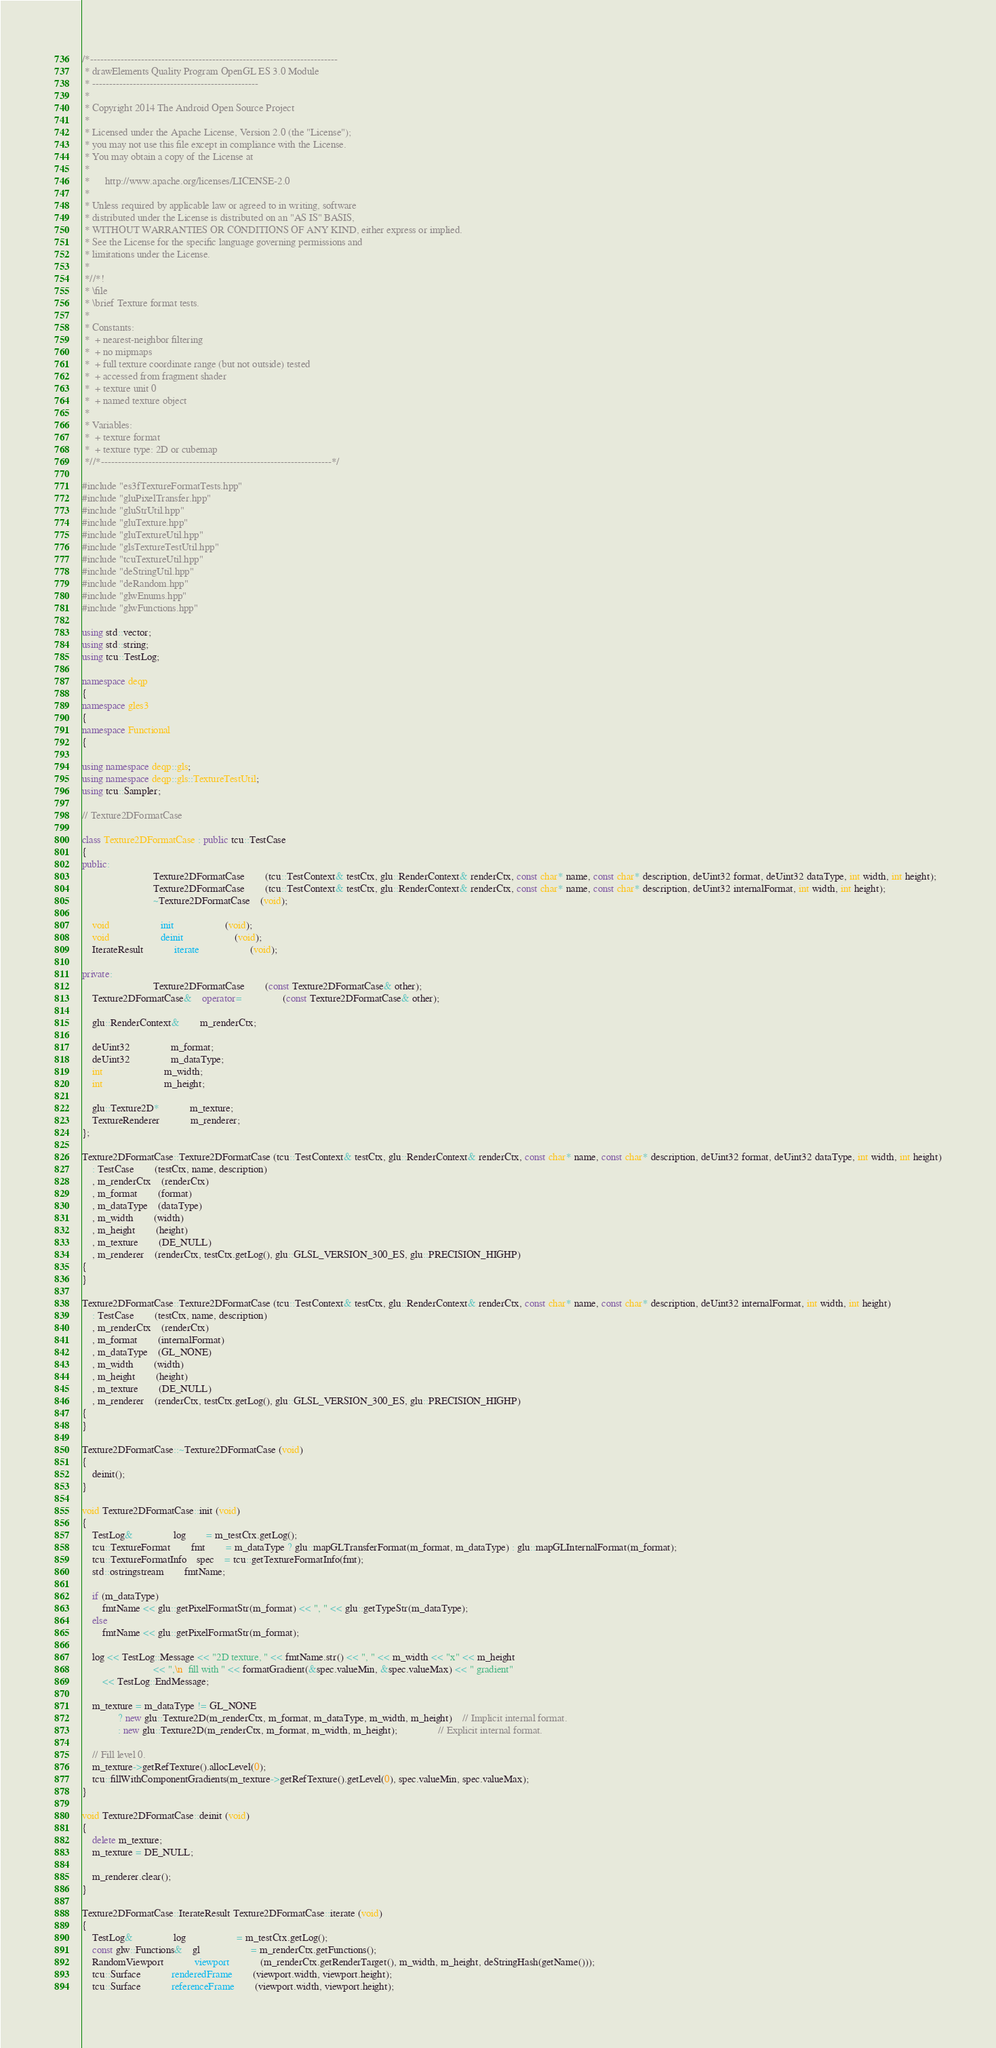<code> <loc_0><loc_0><loc_500><loc_500><_C++_>/*-------------------------------------------------------------------------
 * drawElements Quality Program OpenGL ES 3.0 Module
 * -------------------------------------------------
 *
 * Copyright 2014 The Android Open Source Project
 *
 * Licensed under the Apache License, Version 2.0 (the "License");
 * you may not use this file except in compliance with the License.
 * You may obtain a copy of the License at
 *
 *      http://www.apache.org/licenses/LICENSE-2.0
 *
 * Unless required by applicable law or agreed to in writing, software
 * distributed under the License is distributed on an "AS IS" BASIS,
 * WITHOUT WARRANTIES OR CONDITIONS OF ANY KIND, either express or implied.
 * See the License for the specific language governing permissions and
 * limitations under the License.
 *
 *//*!
 * \file
 * \brief Texture format tests.
 *
 * Constants:
 *  + nearest-neighbor filtering
 *  + no mipmaps
 *  + full texture coordinate range (but not outside) tested
 *  + accessed from fragment shader
 *  + texture unit 0
 *  + named texture object
 *
 * Variables:
 *  + texture format
 *  + texture type: 2D or cubemap
 *//*--------------------------------------------------------------------*/

#include "es3fTextureFormatTests.hpp"
#include "gluPixelTransfer.hpp"
#include "gluStrUtil.hpp"
#include "gluTexture.hpp"
#include "gluTextureUtil.hpp"
#include "glsTextureTestUtil.hpp"
#include "tcuTextureUtil.hpp"
#include "deStringUtil.hpp"
#include "deRandom.hpp"
#include "glwEnums.hpp"
#include "glwFunctions.hpp"

using std::vector;
using std::string;
using tcu::TestLog;

namespace deqp
{
namespace gles3
{
namespace Functional
{

using namespace deqp::gls;
using namespace deqp::gls::TextureTestUtil;
using tcu::Sampler;

// Texture2DFormatCase

class Texture2DFormatCase : public tcu::TestCase
{
public:
							Texture2DFormatCase		(tcu::TestContext& testCtx, glu::RenderContext& renderCtx, const char* name, const char* description, deUint32 format, deUint32 dataType, int width, int height);
							Texture2DFormatCase		(tcu::TestContext& testCtx, glu::RenderContext& renderCtx, const char* name, const char* description, deUint32 internalFormat, int width, int height);
							~Texture2DFormatCase	(void);

	void					init					(void);
	void					deinit					(void);
	IterateResult			iterate					(void);

private:
							Texture2DFormatCase		(const Texture2DFormatCase& other);
	Texture2DFormatCase&	operator=				(const Texture2DFormatCase& other);

	glu::RenderContext&		m_renderCtx;

	deUint32				m_format;
	deUint32				m_dataType;
	int						m_width;
	int						m_height;

	glu::Texture2D*			m_texture;
	TextureRenderer			m_renderer;
};

Texture2DFormatCase::Texture2DFormatCase (tcu::TestContext& testCtx, glu::RenderContext& renderCtx, const char* name, const char* description, deUint32 format, deUint32 dataType, int width, int height)
	: TestCase		(testCtx, name, description)
	, m_renderCtx	(renderCtx)
	, m_format		(format)
	, m_dataType	(dataType)
	, m_width		(width)
	, m_height		(height)
	, m_texture		(DE_NULL)
	, m_renderer	(renderCtx, testCtx.getLog(), glu::GLSL_VERSION_300_ES, glu::PRECISION_HIGHP)
{
}

Texture2DFormatCase::Texture2DFormatCase (tcu::TestContext& testCtx, glu::RenderContext& renderCtx, const char* name, const char* description, deUint32 internalFormat, int width, int height)
	: TestCase		(testCtx, name, description)
	, m_renderCtx	(renderCtx)
	, m_format		(internalFormat)
	, m_dataType	(GL_NONE)
	, m_width		(width)
	, m_height		(height)
	, m_texture		(DE_NULL)
	, m_renderer	(renderCtx, testCtx.getLog(), glu::GLSL_VERSION_300_ES, glu::PRECISION_HIGHP)
{
}

Texture2DFormatCase::~Texture2DFormatCase (void)
{
	deinit();
}

void Texture2DFormatCase::init (void)
{
	TestLog&				log		= m_testCtx.getLog();
	tcu::TextureFormat		fmt		= m_dataType ? glu::mapGLTransferFormat(m_format, m_dataType) : glu::mapGLInternalFormat(m_format);
	tcu::TextureFormatInfo	spec	= tcu::getTextureFormatInfo(fmt);
	std::ostringstream		fmtName;

	if (m_dataType)
		fmtName << glu::getPixelFormatStr(m_format) << ", " << glu::getTypeStr(m_dataType);
	else
		fmtName << glu::getPixelFormatStr(m_format);

	log << TestLog::Message << "2D texture, " << fmtName.str() << ", " << m_width << "x" << m_height
							<< ",\n  fill with " << formatGradient(&spec.valueMin, &spec.valueMax) << " gradient"
		<< TestLog::EndMessage;

	m_texture = m_dataType != GL_NONE
			  ? new glu::Texture2D(m_renderCtx, m_format, m_dataType, m_width, m_height)	// Implicit internal format.
			  : new glu::Texture2D(m_renderCtx, m_format, m_width, m_height);				// Explicit internal format.

	// Fill level 0.
	m_texture->getRefTexture().allocLevel(0);
	tcu::fillWithComponentGradients(m_texture->getRefTexture().getLevel(0), spec.valueMin, spec.valueMax);
}

void Texture2DFormatCase::deinit (void)
{
	delete m_texture;
	m_texture = DE_NULL;

	m_renderer.clear();
}

Texture2DFormatCase::IterateResult Texture2DFormatCase::iterate (void)
{
	TestLog&				log					= m_testCtx.getLog();
	const glw::Functions&	gl					= m_renderCtx.getFunctions();
	RandomViewport			viewport			(m_renderCtx.getRenderTarget(), m_width, m_height, deStringHash(getName()));
	tcu::Surface			renderedFrame		(viewport.width, viewport.height);
	tcu::Surface			referenceFrame		(viewport.width, viewport.height);</code> 